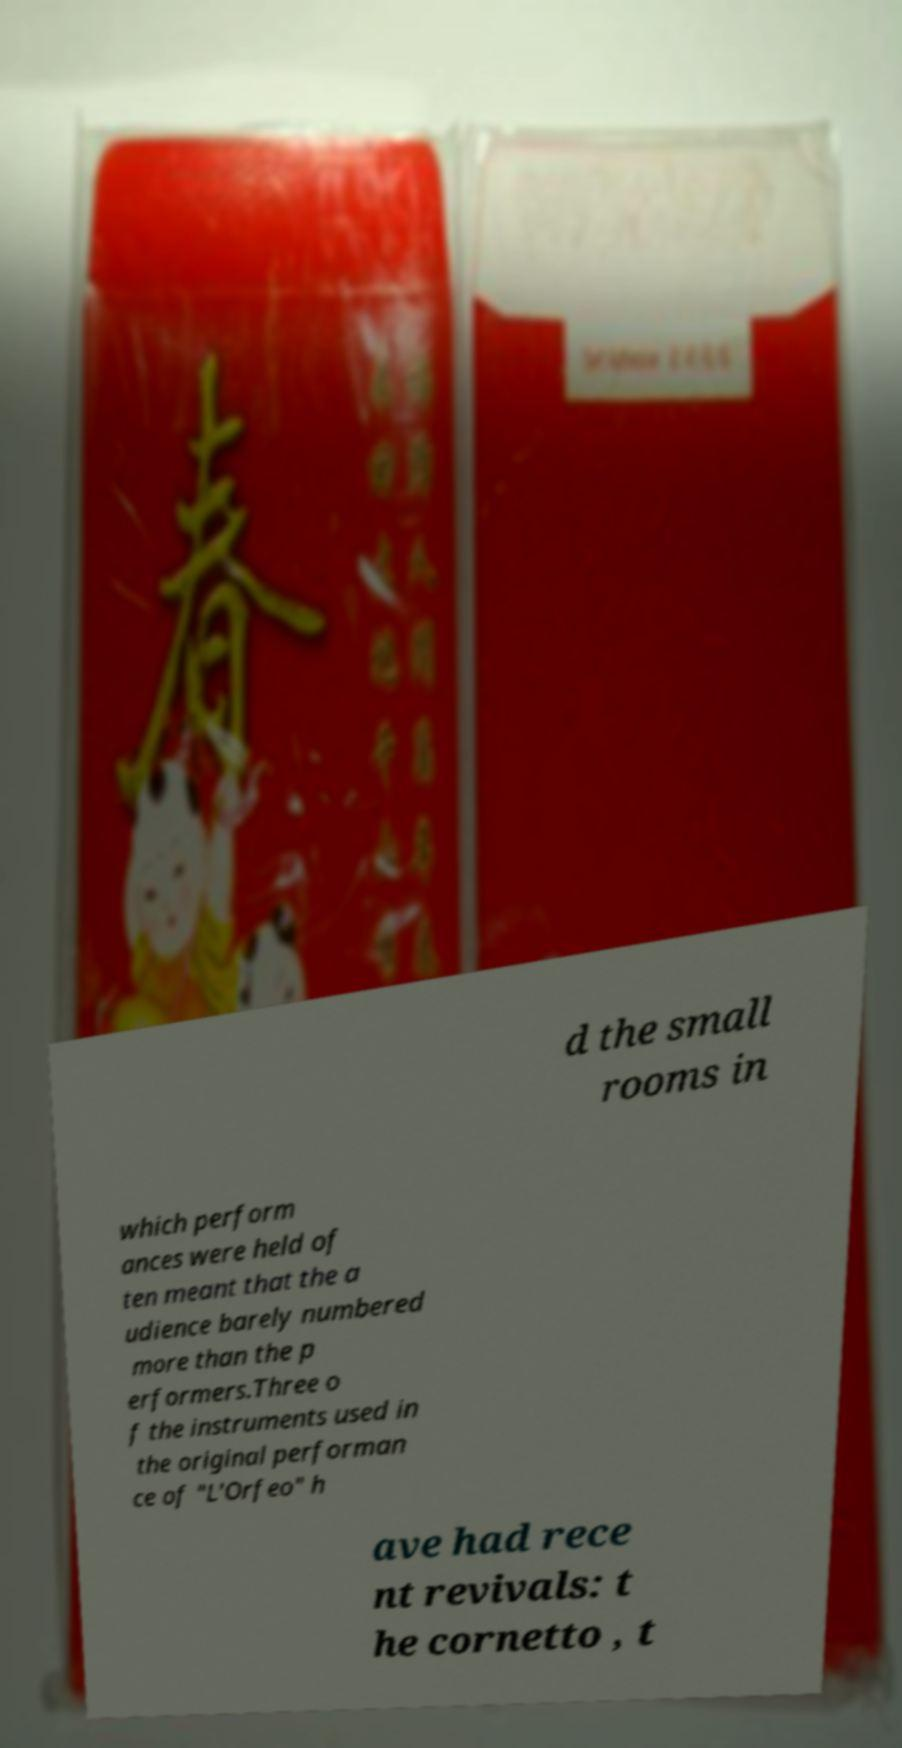Please read and relay the text visible in this image. What does it say? d the small rooms in which perform ances were held of ten meant that the a udience barely numbered more than the p erformers.Three o f the instruments used in the original performan ce of "L'Orfeo" h ave had rece nt revivals: t he cornetto , t 